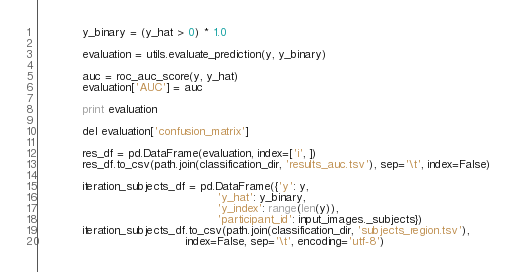Convert code to text. <code><loc_0><loc_0><loc_500><loc_500><_Python_>            y_binary = (y_hat > 0) * 1.0

            evaluation = utils.evaluate_prediction(y, y_binary)

            auc = roc_auc_score(y, y_hat)
            evaluation['AUC'] = auc

            print evaluation

            del evaluation['confusion_matrix']

            res_df = pd.DataFrame(evaluation, index=['i', ])
            res_df.to_csv(path.join(classification_dir, 'results_auc.tsv'), sep='\t', index=False)

            iteration_subjects_df = pd.DataFrame({'y': y,
                                                  'y_hat': y_binary,
                                                  'y_index': range(len(y)),
                                                  'participant_id': input_images._subjects})
            iteration_subjects_df.to_csv(path.join(classification_dir, 'subjects_region.tsv'),
                                         index=False, sep='\t', encoding='utf-8')
</code> 